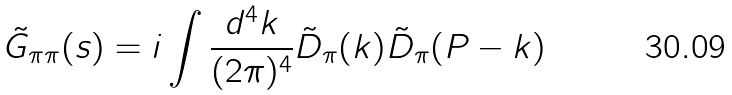<formula> <loc_0><loc_0><loc_500><loc_500>\tilde { G } _ { \pi \pi } ( s ) = i \int \frac { d ^ { 4 } k } { ( 2 \pi ) ^ { 4 } } \tilde { D } _ { \pi } ( k ) \tilde { D } _ { \pi } ( P - k )</formula> 